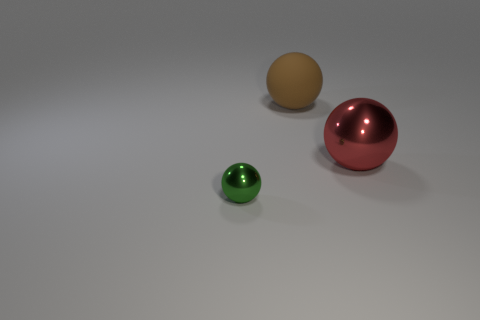Are there any shiny objects that have the same color as the large matte object?
Your response must be concise. No. There is a big object that is behind the object on the right side of the brown sphere; what color is it?
Ensure brevity in your answer.  Brown. Is the number of balls that are to the right of the large rubber object less than the number of large red metallic balls in front of the small metal thing?
Offer a very short reply. No. Do the green ball and the brown rubber sphere have the same size?
Your answer should be compact. No. What shape is the object that is in front of the large brown rubber ball and behind the small green metal thing?
Offer a terse response. Sphere. What number of big things have the same material as the small ball?
Provide a succinct answer. 1. How many shiny objects are on the left side of the shiny object that is to the right of the small green thing?
Keep it short and to the point. 1. What is the shape of the thing on the right side of the large thing on the left side of the metallic thing to the right of the small metal thing?
Give a very brief answer. Sphere. What number of things are small blue spheres or green metal objects?
Your answer should be very brief. 1. The other shiny object that is the same size as the brown thing is what color?
Offer a terse response. Red. 